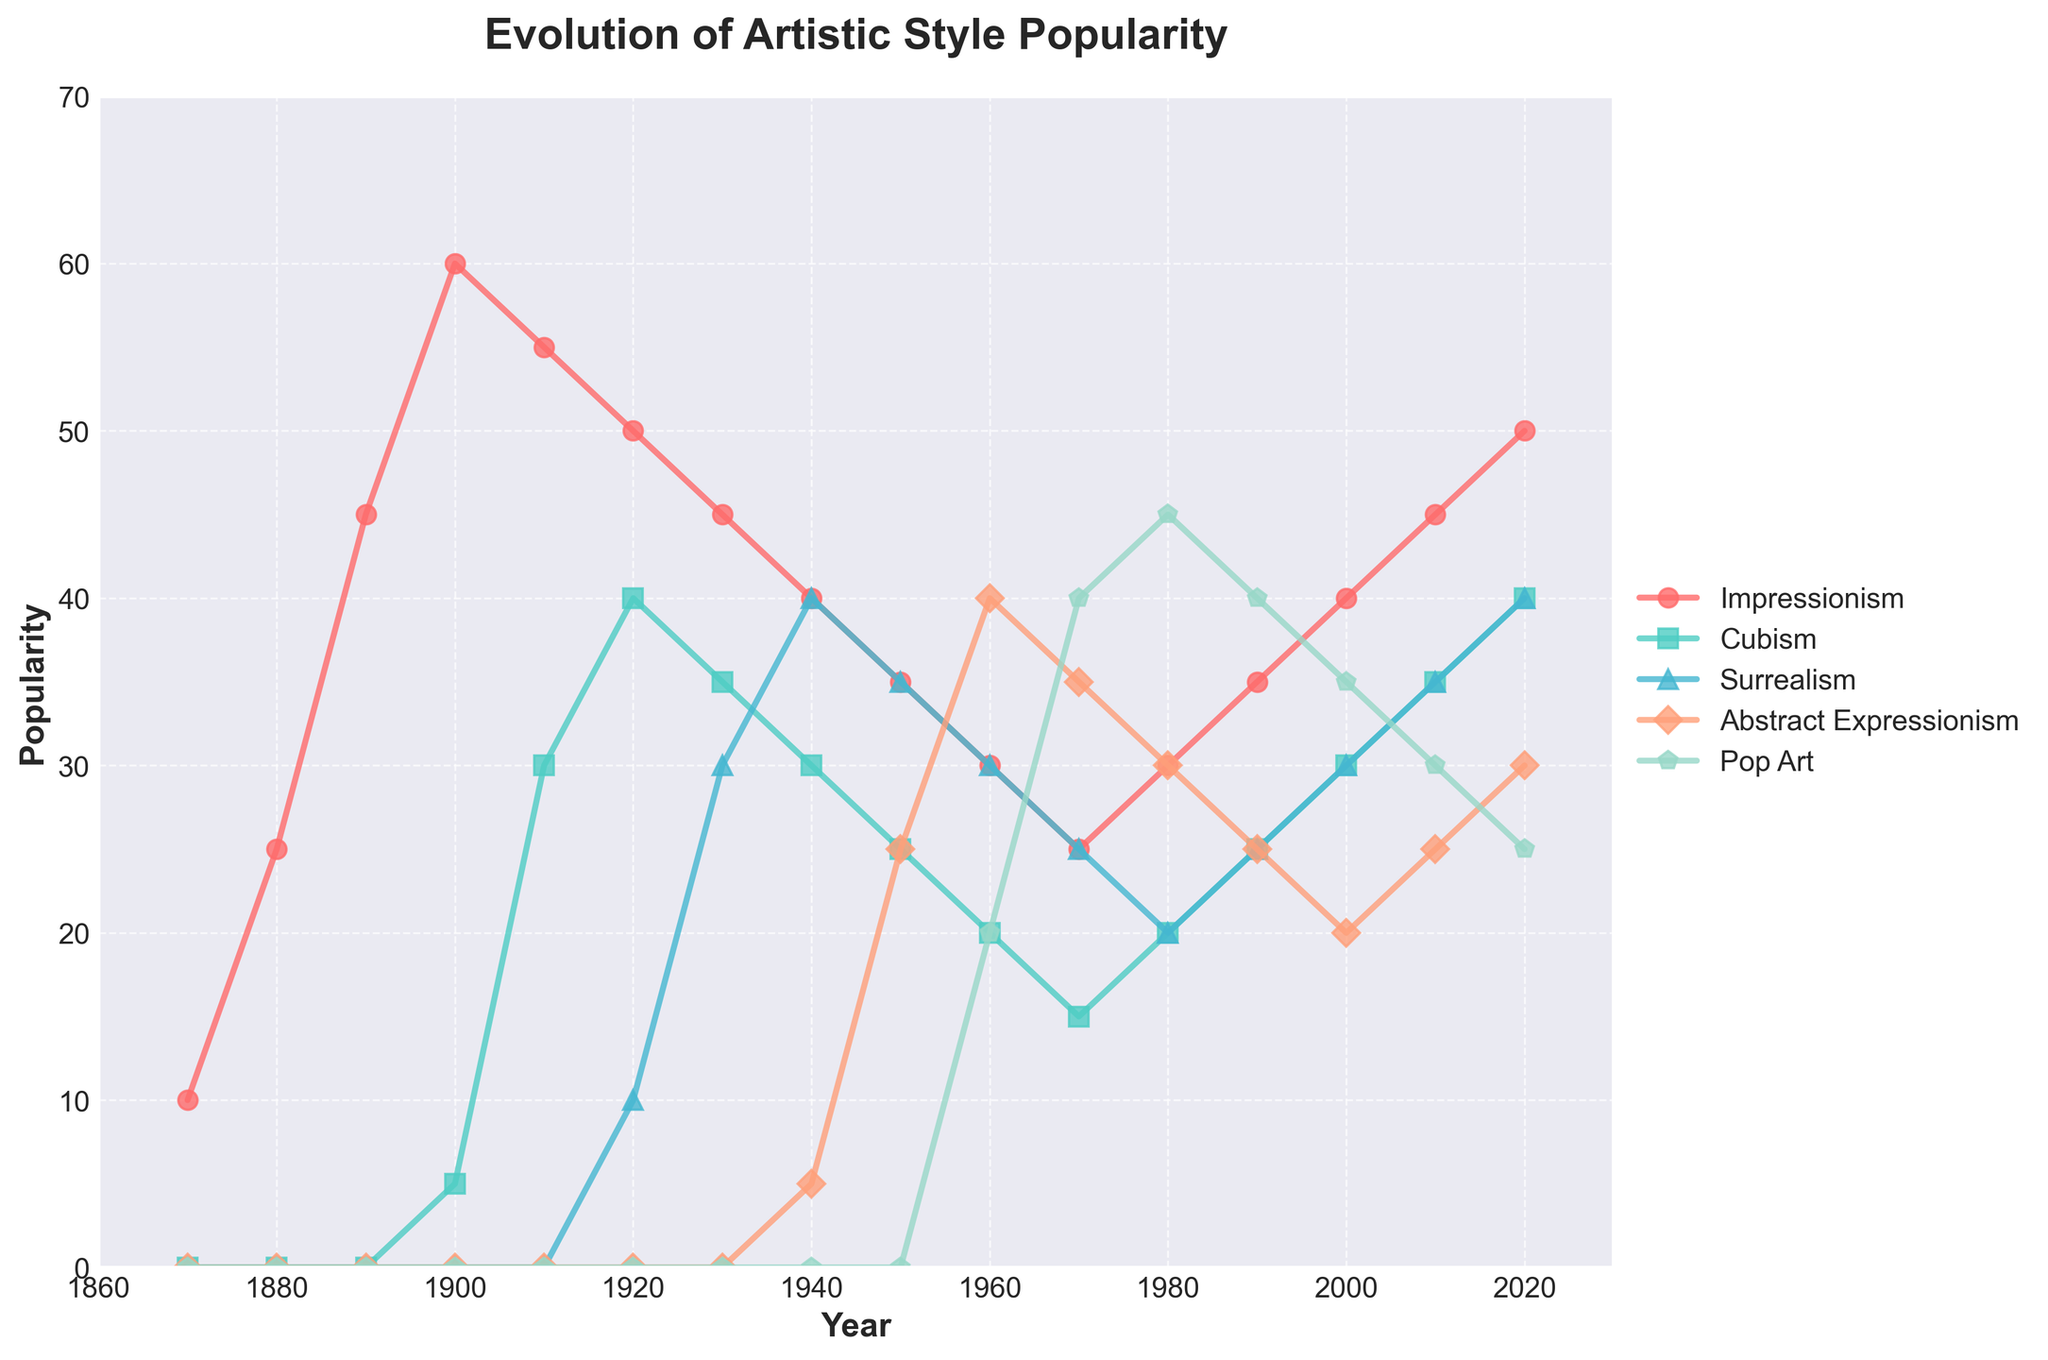What was the popularity of Impressionism in 1920 compared to 2020? In the figure, locate the markers for Impressionism in 1920 and 2020. The value in 1920 is at 50, and in 2020, it is at 50. Thus, the popularity remained the same.
Answer: Same Which artistic style had the highest popularity in 1940? Look at the chart for the year 1940 and compare the values. Impressionism is at 40, Cubism is at 30, Surrealism is at 40, Abstract Expressionism is at 5, and Pop Art is not present. Both Impressionism and Surrealism have the highest value of 40.
Answer: Impressionism, Surrealism How did the popularity of Cubism change from 1900 to 1920? Compare the values of Cubism in 1900 and 1920. In 1900, it is at 5 and in 1920, it is at 40. Thus, it increased by 35.
Answer: Increased by 35 What is the average popularity of Surrealism from 1920 to 1940? Sum the popularity values of Surrealism from 1920 (10), 1930 (30), and 1940 (40). The total is 80. There are 3 values, so divide 80 by 3 to get the average, which is approximately 26.67.
Answer: 26.67 During which decade did Abstract Expressionism reach its highest point? Check the values of Abstract Expressionism throughout the decades. The highest value is 40 in 1960.
Answer: 1960s Which artistic movement had a significant rise between 1950 and 1970? Compare the popularity trends between 1950 and 1970. Pop Art increased from 0 to 40 during this period, showing the most significant rise.
Answer: Pop Art By how much did the popularity of Impressionism decline from 1900 to 1970? In 1900, Impressionism is at 60 and by 1970, it is at 25. Subtract 25 from 60 to find the decline, which is 35.
Answer: 35 Which artistic style shows a continuous increase in popularity from 1980 to 2020? Analyze each style's trend from 1980 to 2020. Impressionism consistently increases from 30 to 50 over the period.
Answer: Impressionism Compare the popularity trends of Impressionism and Surrealism in the 1980s. In the 1980s, Impressionism increased from 25 to 30, while Surrealism decreased from 25 to 20.
Answer: Impressionism increased, Surrealism decreased 